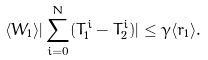Convert formula to latex. <formula><loc_0><loc_0><loc_500><loc_500>\langle W _ { 1 } \rangle | \sum _ { i = 0 } ^ { N } ( T ^ { i } _ { 1 } - T ^ { i } _ { 2 } ) | \leq \gamma \langle r _ { 1 } \rangle .</formula> 